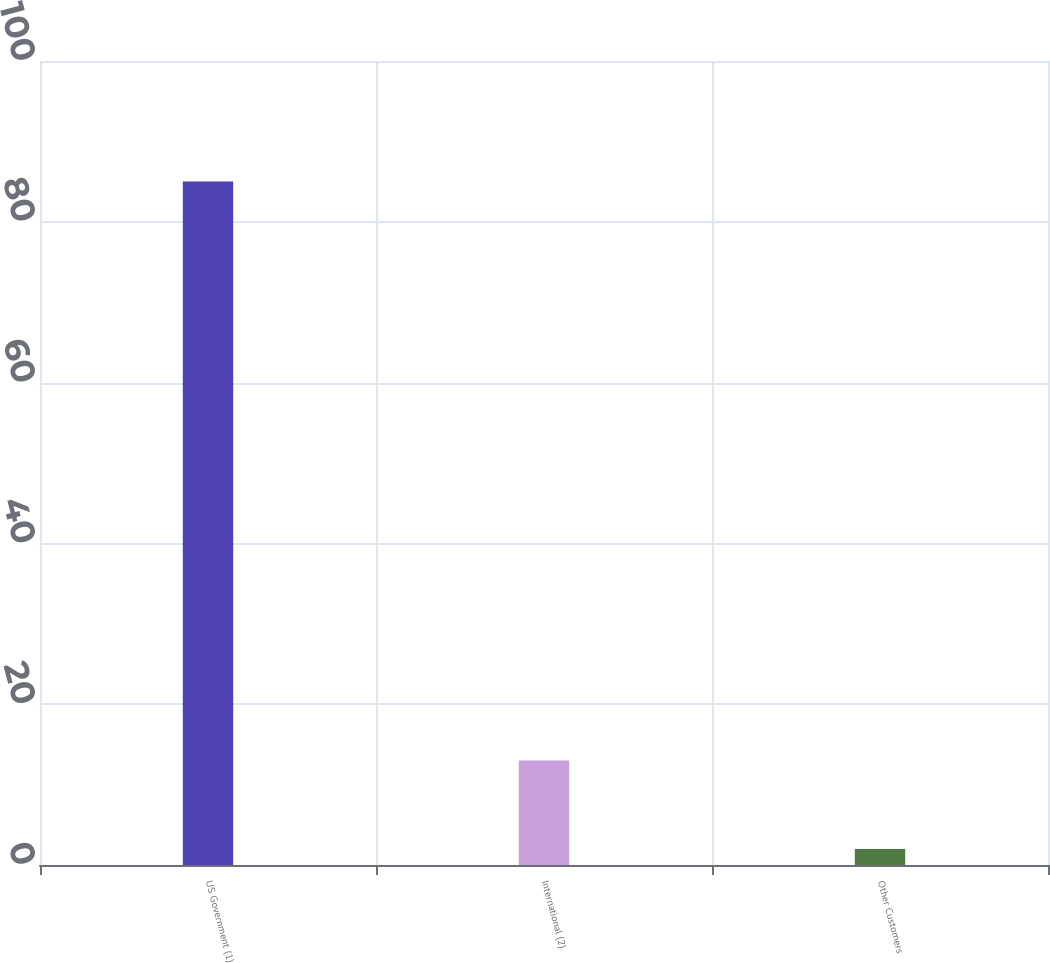<chart> <loc_0><loc_0><loc_500><loc_500><bar_chart><fcel>US Government (1)<fcel>International (2)<fcel>Other Customers<nl><fcel>85<fcel>13<fcel>2<nl></chart> 